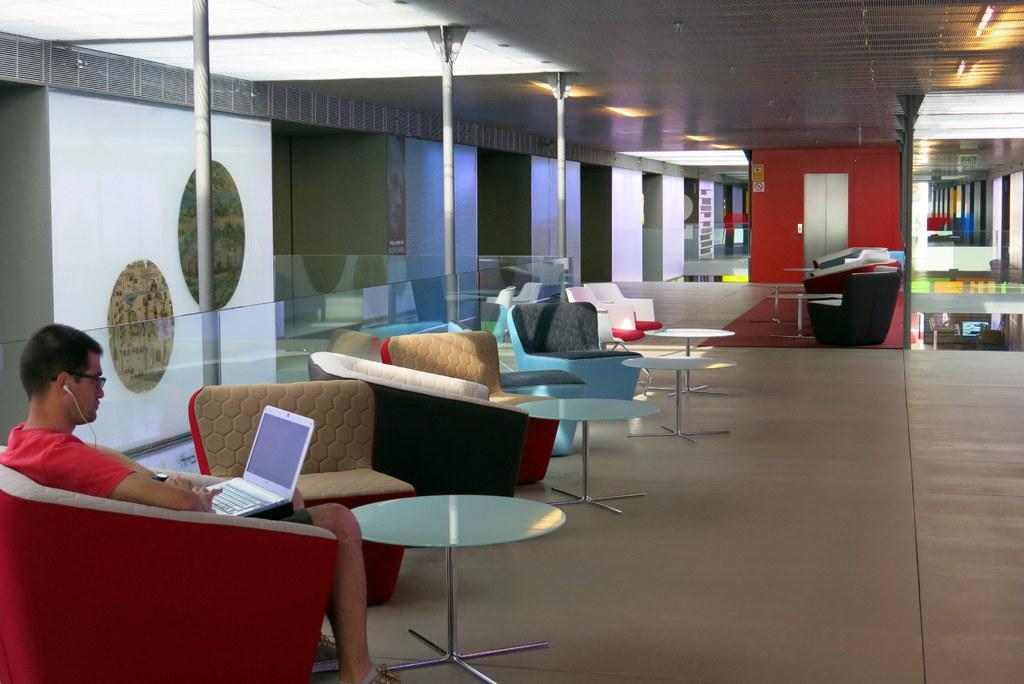Please provide a concise description of this image. Here we can see chairs and tables present and in the left bottom we can see a man sitting on a chair with laptop in his lap 